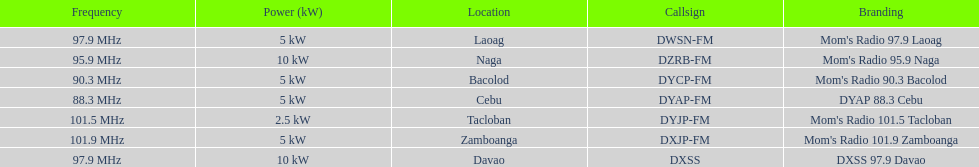What is the difference in kw between naga and bacolod radio? 5 kW. 